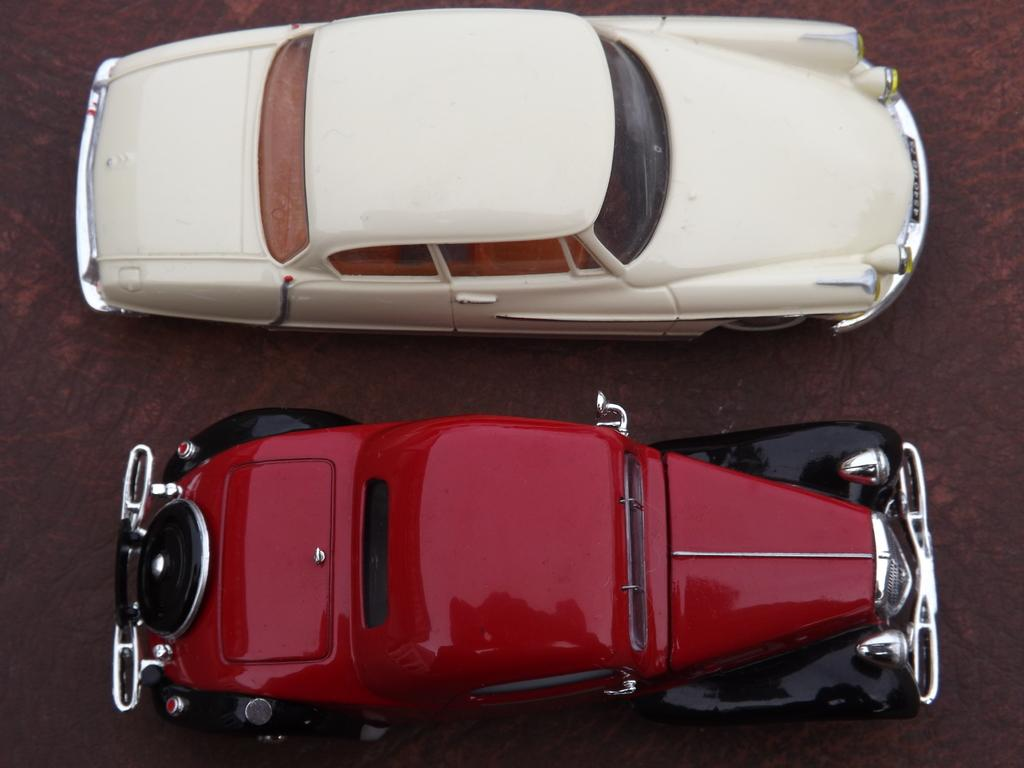How many cars are in the image? There are two cars in the image. Where are the cars located in the image? The cars are on the ground in the image. What is the value of the cars in the image? The value of the cars cannot be determined from the image alone, as it does not provide any information about the make, model, or condition of the cars. 